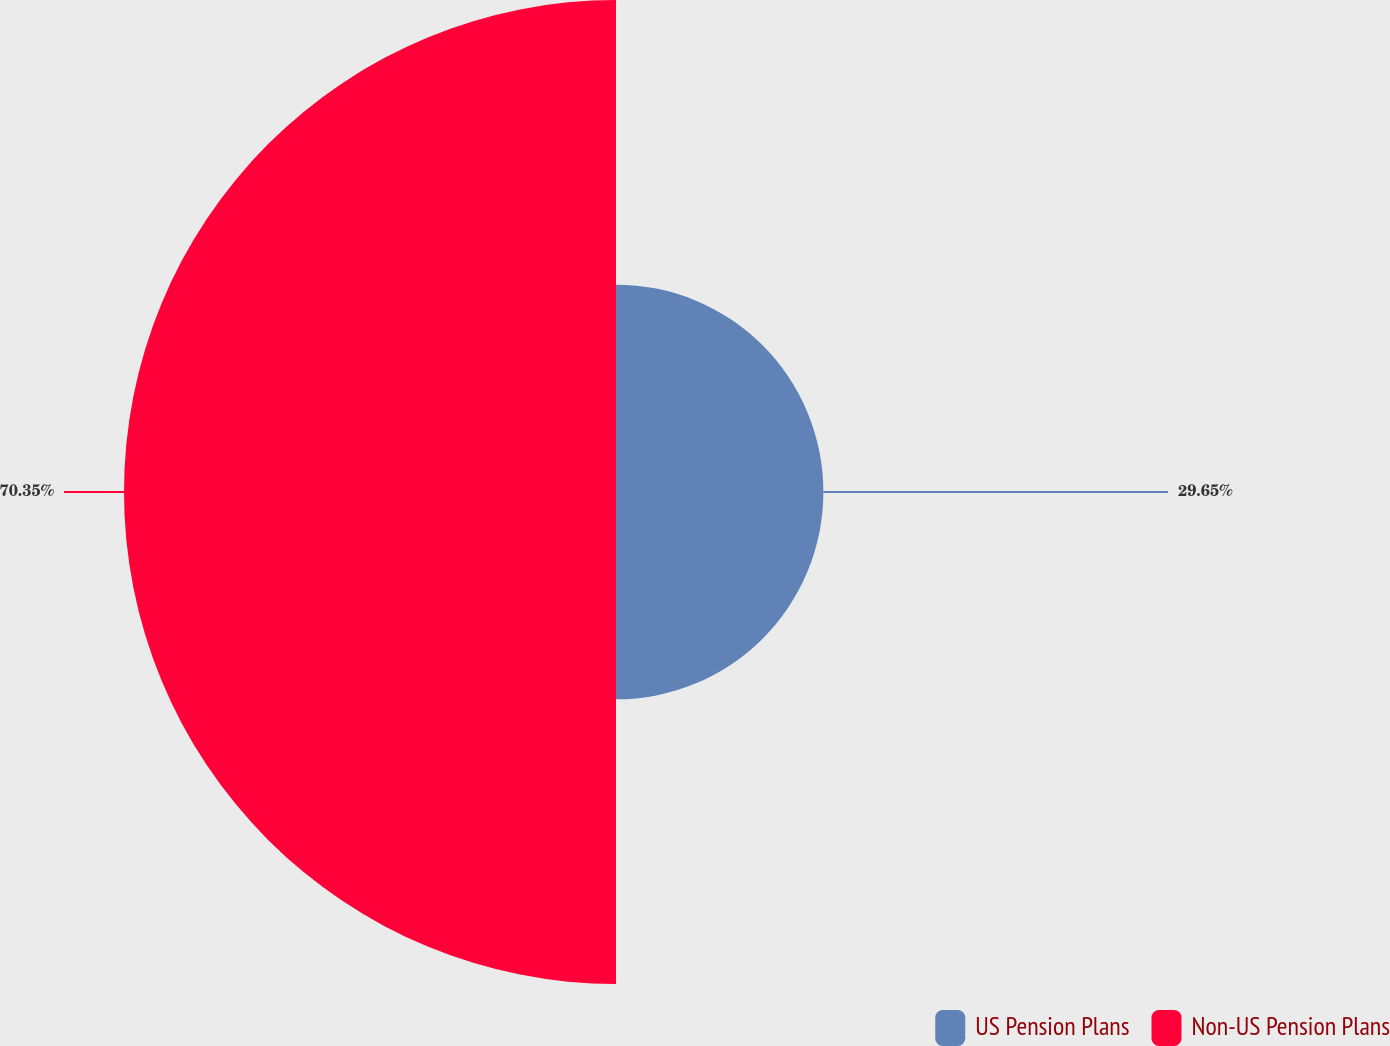Convert chart to OTSL. <chart><loc_0><loc_0><loc_500><loc_500><pie_chart><fcel>US Pension Plans<fcel>Non-US Pension Plans<nl><fcel>29.65%<fcel>70.35%<nl></chart> 